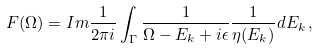<formula> <loc_0><loc_0><loc_500><loc_500>F ( \Omega ) = I m \frac { 1 } { 2 \pi i } \int _ { \Gamma } \frac { 1 } { \Omega - E _ { k } + i \epsilon } \frac { 1 } { \eta ( E _ { k } ) } d E _ { k } \, ,</formula> 